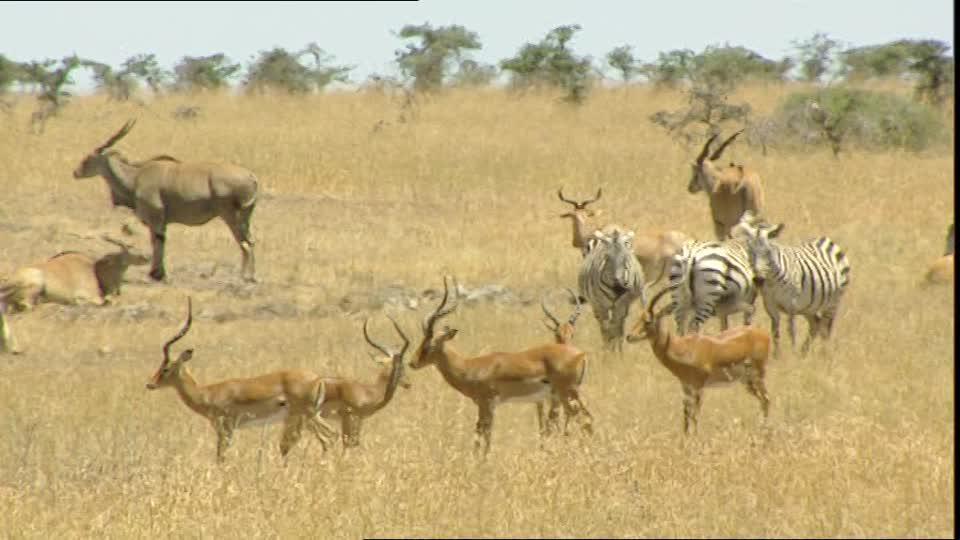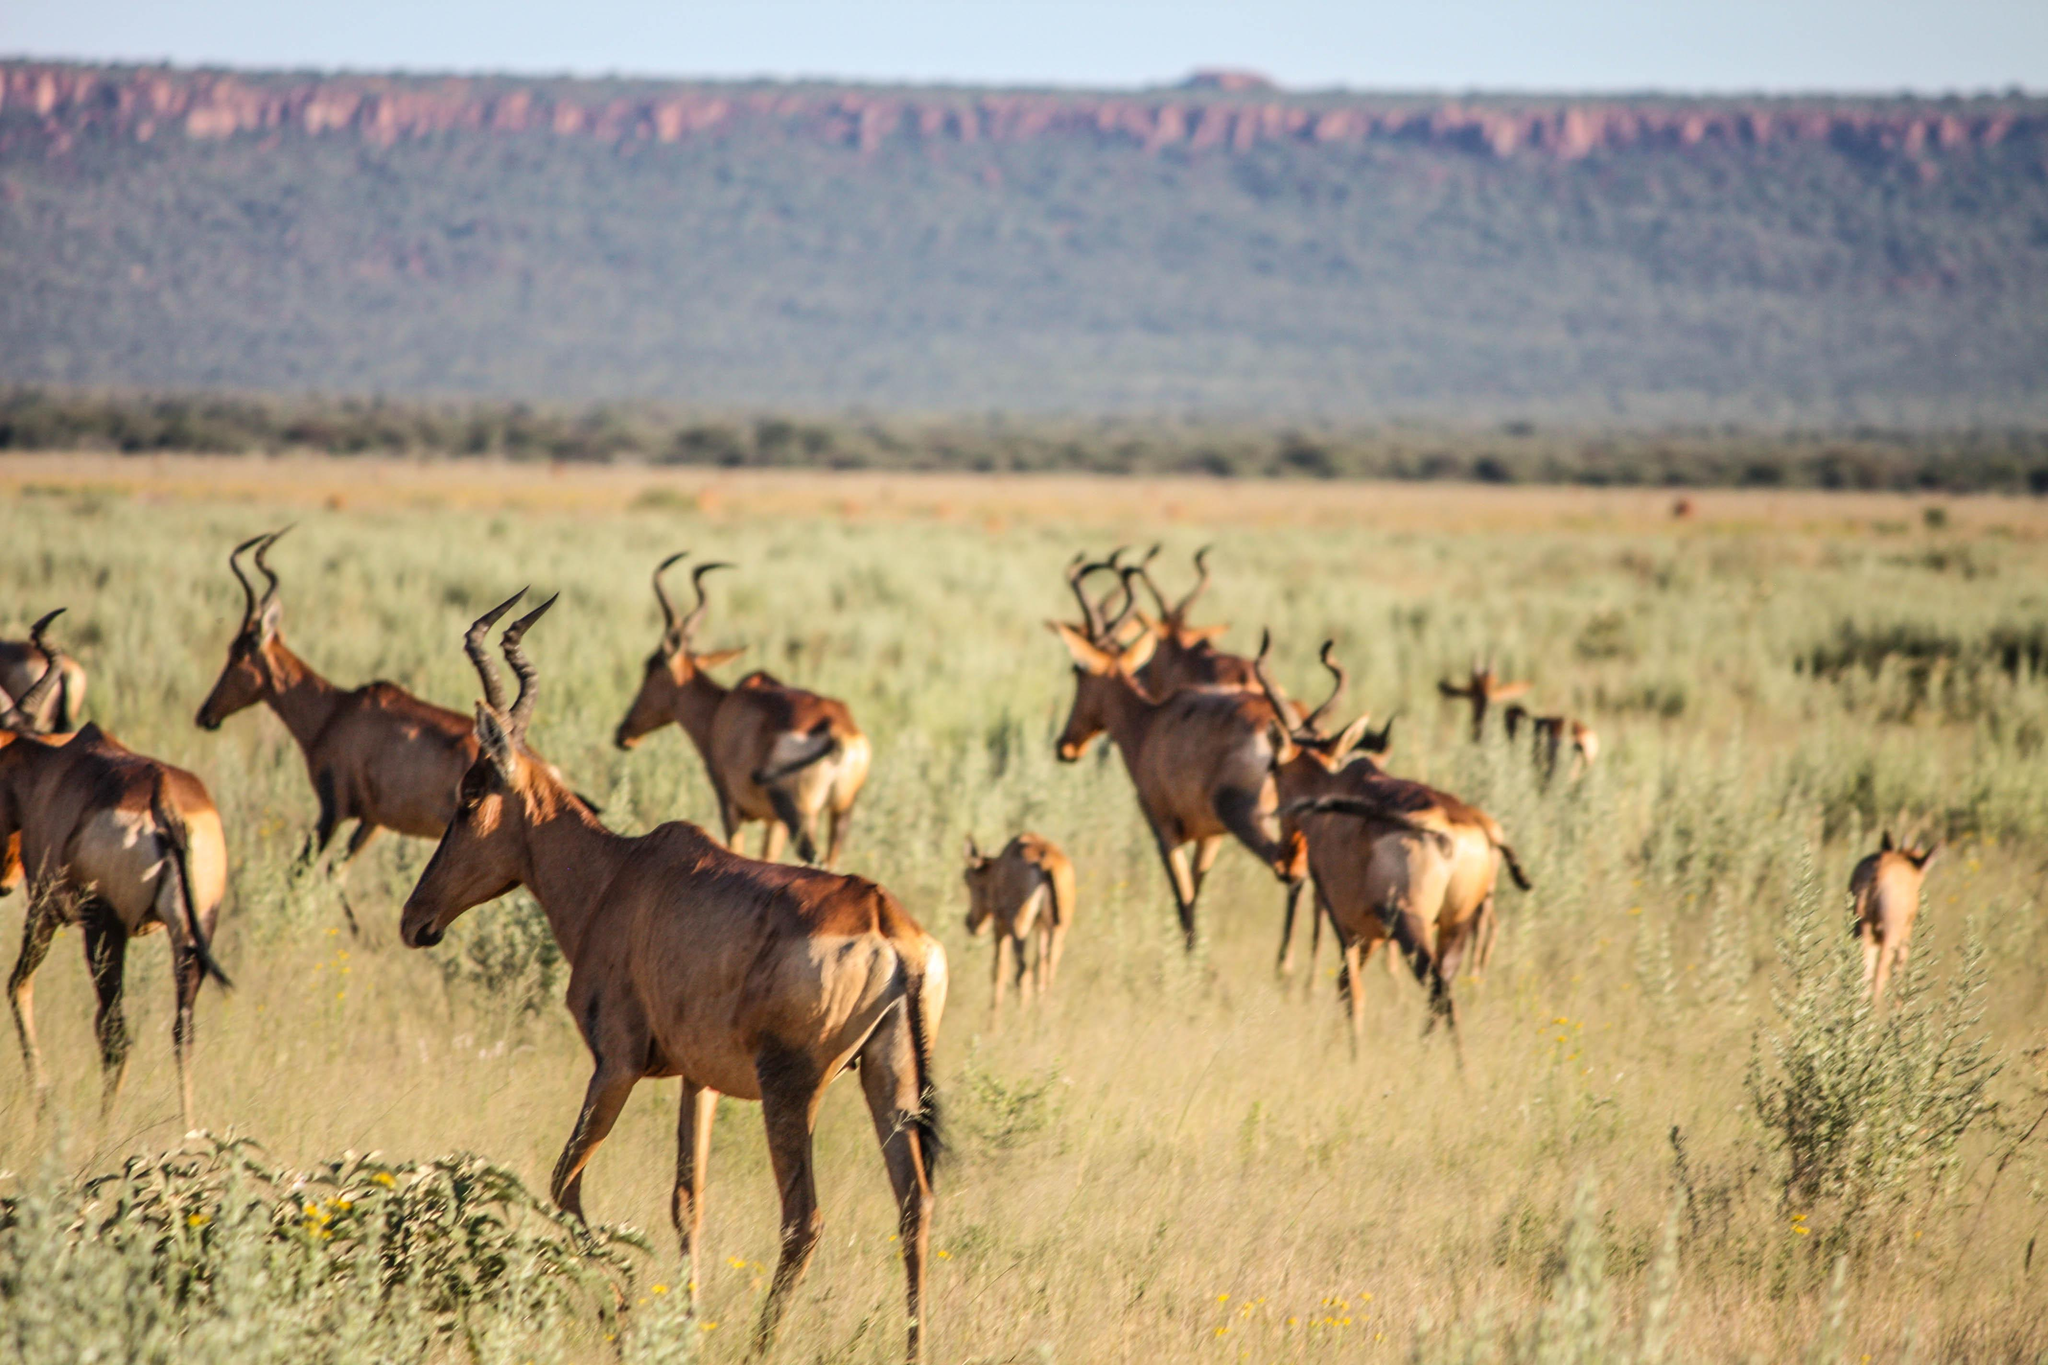The first image is the image on the left, the second image is the image on the right. For the images displayed, is the sentence "There are no more than three animals in the image on the right." factually correct? Answer yes or no. No. The first image is the image on the left, the second image is the image on the right. Analyze the images presented: Is the assertion "The right image contains no more than three antelope." valid? Answer yes or no. No. 